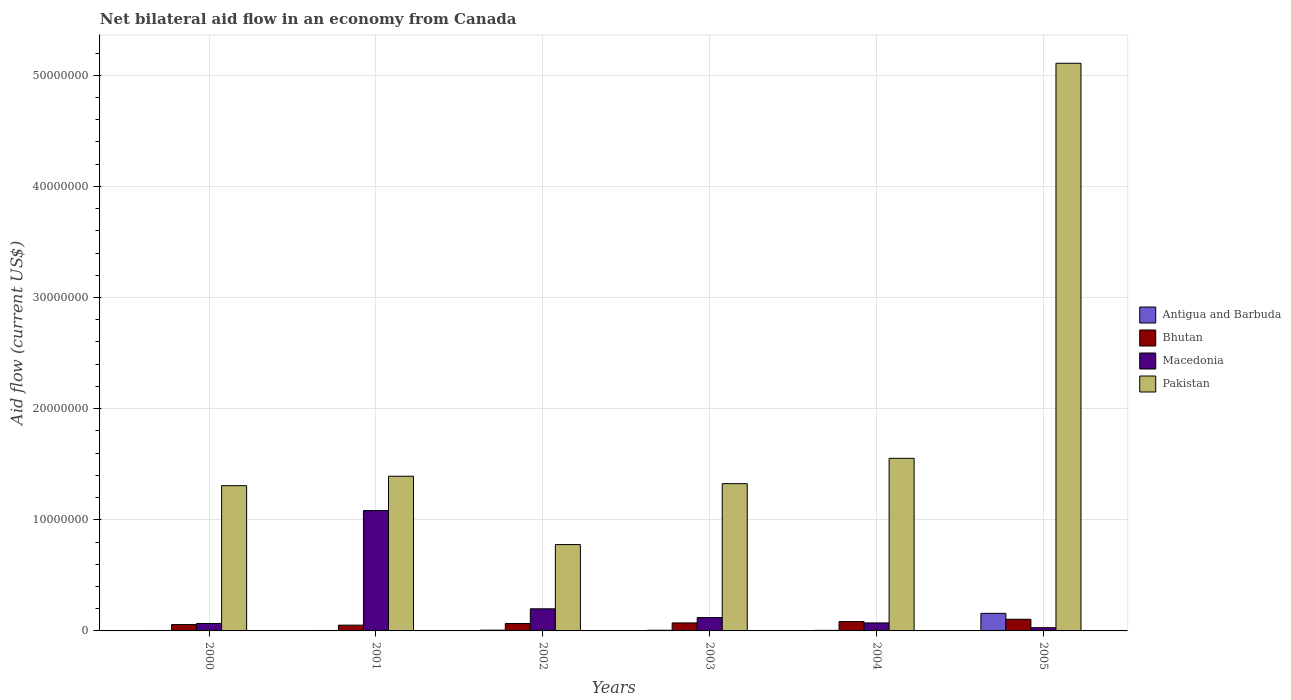How many different coloured bars are there?
Provide a short and direct response. 4. Are the number of bars per tick equal to the number of legend labels?
Provide a short and direct response. Yes. Are the number of bars on each tick of the X-axis equal?
Offer a terse response. Yes. How many bars are there on the 3rd tick from the right?
Give a very brief answer. 4. What is the label of the 3rd group of bars from the left?
Your answer should be very brief. 2002. In how many cases, is the number of bars for a given year not equal to the number of legend labels?
Make the answer very short. 0. Across all years, what is the maximum net bilateral aid flow in Pakistan?
Your response must be concise. 5.11e+07. Across all years, what is the minimum net bilateral aid flow in Macedonia?
Your answer should be very brief. 2.90e+05. In which year was the net bilateral aid flow in Macedonia maximum?
Provide a succinct answer. 2001. In which year was the net bilateral aid flow in Antigua and Barbuda minimum?
Give a very brief answer. 2000. What is the total net bilateral aid flow in Macedonia in the graph?
Your response must be concise. 1.57e+07. What is the difference between the net bilateral aid flow in Pakistan in 2000 and that in 2001?
Make the answer very short. -8.50e+05. What is the difference between the net bilateral aid flow in Macedonia in 2003 and the net bilateral aid flow in Antigua and Barbuda in 2002?
Ensure brevity in your answer.  1.13e+06. What is the average net bilateral aid flow in Pakistan per year?
Provide a succinct answer. 1.91e+07. In the year 2000, what is the difference between the net bilateral aid flow in Pakistan and net bilateral aid flow in Bhutan?
Provide a succinct answer. 1.25e+07. What is the ratio of the net bilateral aid flow in Antigua and Barbuda in 2000 to that in 2005?
Provide a short and direct response. 0.03. What is the difference between the highest and the second highest net bilateral aid flow in Macedonia?
Your answer should be compact. 8.84e+06. What is the difference between the highest and the lowest net bilateral aid flow in Pakistan?
Your answer should be compact. 4.33e+07. In how many years, is the net bilateral aid flow in Pakistan greater than the average net bilateral aid flow in Pakistan taken over all years?
Keep it short and to the point. 1. Is the sum of the net bilateral aid flow in Antigua and Barbuda in 2000 and 2004 greater than the maximum net bilateral aid flow in Bhutan across all years?
Offer a terse response. No. What does the 4th bar from the right in 2003 represents?
Make the answer very short. Antigua and Barbuda. Is it the case that in every year, the sum of the net bilateral aid flow in Pakistan and net bilateral aid flow in Antigua and Barbuda is greater than the net bilateral aid flow in Bhutan?
Your response must be concise. Yes. What is the difference between two consecutive major ticks on the Y-axis?
Your answer should be compact. 1.00e+07. Are the values on the major ticks of Y-axis written in scientific E-notation?
Your response must be concise. No. Does the graph contain grids?
Provide a succinct answer. Yes. Where does the legend appear in the graph?
Provide a short and direct response. Center right. How many legend labels are there?
Offer a very short reply. 4. What is the title of the graph?
Offer a very short reply. Net bilateral aid flow in an economy from Canada. What is the Aid flow (current US$) in Antigua and Barbuda in 2000?
Provide a succinct answer. 4.00e+04. What is the Aid flow (current US$) in Bhutan in 2000?
Your response must be concise. 5.70e+05. What is the Aid flow (current US$) of Macedonia in 2000?
Offer a terse response. 6.70e+05. What is the Aid flow (current US$) of Pakistan in 2000?
Your answer should be compact. 1.31e+07. What is the Aid flow (current US$) of Antigua and Barbuda in 2001?
Offer a very short reply. 4.00e+04. What is the Aid flow (current US$) in Bhutan in 2001?
Provide a succinct answer. 5.20e+05. What is the Aid flow (current US$) of Macedonia in 2001?
Your response must be concise. 1.08e+07. What is the Aid flow (current US$) in Pakistan in 2001?
Ensure brevity in your answer.  1.39e+07. What is the Aid flow (current US$) of Antigua and Barbuda in 2002?
Give a very brief answer. 7.00e+04. What is the Aid flow (current US$) of Bhutan in 2002?
Offer a very short reply. 6.70e+05. What is the Aid flow (current US$) of Macedonia in 2002?
Provide a short and direct response. 1.99e+06. What is the Aid flow (current US$) in Pakistan in 2002?
Your response must be concise. 7.77e+06. What is the Aid flow (current US$) in Bhutan in 2003?
Your answer should be very brief. 7.20e+05. What is the Aid flow (current US$) of Macedonia in 2003?
Your response must be concise. 1.20e+06. What is the Aid flow (current US$) of Pakistan in 2003?
Your answer should be compact. 1.32e+07. What is the Aid flow (current US$) of Bhutan in 2004?
Ensure brevity in your answer.  8.40e+05. What is the Aid flow (current US$) of Macedonia in 2004?
Ensure brevity in your answer.  7.20e+05. What is the Aid flow (current US$) in Pakistan in 2004?
Give a very brief answer. 1.55e+07. What is the Aid flow (current US$) in Antigua and Barbuda in 2005?
Give a very brief answer. 1.58e+06. What is the Aid flow (current US$) in Bhutan in 2005?
Your answer should be compact. 1.05e+06. What is the Aid flow (current US$) in Macedonia in 2005?
Make the answer very short. 2.90e+05. What is the Aid flow (current US$) in Pakistan in 2005?
Make the answer very short. 5.11e+07. Across all years, what is the maximum Aid flow (current US$) in Antigua and Barbuda?
Your answer should be very brief. 1.58e+06. Across all years, what is the maximum Aid flow (current US$) of Bhutan?
Your response must be concise. 1.05e+06. Across all years, what is the maximum Aid flow (current US$) of Macedonia?
Keep it short and to the point. 1.08e+07. Across all years, what is the maximum Aid flow (current US$) of Pakistan?
Provide a succinct answer. 5.11e+07. Across all years, what is the minimum Aid flow (current US$) of Antigua and Barbuda?
Ensure brevity in your answer.  4.00e+04. Across all years, what is the minimum Aid flow (current US$) of Bhutan?
Your answer should be very brief. 5.20e+05. Across all years, what is the minimum Aid flow (current US$) of Macedonia?
Provide a short and direct response. 2.90e+05. Across all years, what is the minimum Aid flow (current US$) of Pakistan?
Your answer should be compact. 7.77e+06. What is the total Aid flow (current US$) of Antigua and Barbuda in the graph?
Provide a succinct answer. 1.84e+06. What is the total Aid flow (current US$) in Bhutan in the graph?
Provide a succinct answer. 4.37e+06. What is the total Aid flow (current US$) in Macedonia in the graph?
Ensure brevity in your answer.  1.57e+07. What is the total Aid flow (current US$) in Pakistan in the graph?
Offer a very short reply. 1.15e+08. What is the difference between the Aid flow (current US$) in Macedonia in 2000 and that in 2001?
Offer a very short reply. -1.02e+07. What is the difference between the Aid flow (current US$) of Pakistan in 2000 and that in 2001?
Your answer should be compact. -8.50e+05. What is the difference between the Aid flow (current US$) of Antigua and Barbuda in 2000 and that in 2002?
Give a very brief answer. -3.00e+04. What is the difference between the Aid flow (current US$) of Macedonia in 2000 and that in 2002?
Provide a short and direct response. -1.32e+06. What is the difference between the Aid flow (current US$) of Pakistan in 2000 and that in 2002?
Provide a succinct answer. 5.30e+06. What is the difference between the Aid flow (current US$) in Bhutan in 2000 and that in 2003?
Make the answer very short. -1.50e+05. What is the difference between the Aid flow (current US$) of Macedonia in 2000 and that in 2003?
Make the answer very short. -5.30e+05. What is the difference between the Aid flow (current US$) of Pakistan in 2000 and that in 2003?
Ensure brevity in your answer.  -1.80e+05. What is the difference between the Aid flow (current US$) of Antigua and Barbuda in 2000 and that in 2004?
Provide a short and direct response. -10000. What is the difference between the Aid flow (current US$) in Bhutan in 2000 and that in 2004?
Keep it short and to the point. -2.70e+05. What is the difference between the Aid flow (current US$) of Pakistan in 2000 and that in 2004?
Your response must be concise. -2.46e+06. What is the difference between the Aid flow (current US$) in Antigua and Barbuda in 2000 and that in 2005?
Offer a terse response. -1.54e+06. What is the difference between the Aid flow (current US$) in Bhutan in 2000 and that in 2005?
Provide a short and direct response. -4.80e+05. What is the difference between the Aid flow (current US$) in Macedonia in 2000 and that in 2005?
Your answer should be compact. 3.80e+05. What is the difference between the Aid flow (current US$) of Pakistan in 2000 and that in 2005?
Keep it short and to the point. -3.80e+07. What is the difference between the Aid flow (current US$) in Antigua and Barbuda in 2001 and that in 2002?
Keep it short and to the point. -3.00e+04. What is the difference between the Aid flow (current US$) of Bhutan in 2001 and that in 2002?
Your answer should be very brief. -1.50e+05. What is the difference between the Aid flow (current US$) in Macedonia in 2001 and that in 2002?
Give a very brief answer. 8.84e+06. What is the difference between the Aid flow (current US$) in Pakistan in 2001 and that in 2002?
Your answer should be very brief. 6.15e+06. What is the difference between the Aid flow (current US$) in Antigua and Barbuda in 2001 and that in 2003?
Your response must be concise. -2.00e+04. What is the difference between the Aid flow (current US$) of Bhutan in 2001 and that in 2003?
Your response must be concise. -2.00e+05. What is the difference between the Aid flow (current US$) of Macedonia in 2001 and that in 2003?
Keep it short and to the point. 9.63e+06. What is the difference between the Aid flow (current US$) of Pakistan in 2001 and that in 2003?
Make the answer very short. 6.70e+05. What is the difference between the Aid flow (current US$) in Antigua and Barbuda in 2001 and that in 2004?
Your response must be concise. -10000. What is the difference between the Aid flow (current US$) in Bhutan in 2001 and that in 2004?
Give a very brief answer. -3.20e+05. What is the difference between the Aid flow (current US$) in Macedonia in 2001 and that in 2004?
Provide a succinct answer. 1.01e+07. What is the difference between the Aid flow (current US$) in Pakistan in 2001 and that in 2004?
Provide a short and direct response. -1.61e+06. What is the difference between the Aid flow (current US$) in Antigua and Barbuda in 2001 and that in 2005?
Provide a short and direct response. -1.54e+06. What is the difference between the Aid flow (current US$) in Bhutan in 2001 and that in 2005?
Provide a succinct answer. -5.30e+05. What is the difference between the Aid flow (current US$) of Macedonia in 2001 and that in 2005?
Offer a terse response. 1.05e+07. What is the difference between the Aid flow (current US$) in Pakistan in 2001 and that in 2005?
Give a very brief answer. -3.72e+07. What is the difference between the Aid flow (current US$) in Macedonia in 2002 and that in 2003?
Provide a succinct answer. 7.90e+05. What is the difference between the Aid flow (current US$) in Pakistan in 2002 and that in 2003?
Your response must be concise. -5.48e+06. What is the difference between the Aid flow (current US$) in Macedonia in 2002 and that in 2004?
Your answer should be very brief. 1.27e+06. What is the difference between the Aid flow (current US$) in Pakistan in 2002 and that in 2004?
Ensure brevity in your answer.  -7.76e+06. What is the difference between the Aid flow (current US$) of Antigua and Barbuda in 2002 and that in 2005?
Offer a very short reply. -1.51e+06. What is the difference between the Aid flow (current US$) in Bhutan in 2002 and that in 2005?
Your answer should be very brief. -3.80e+05. What is the difference between the Aid flow (current US$) in Macedonia in 2002 and that in 2005?
Your response must be concise. 1.70e+06. What is the difference between the Aid flow (current US$) in Pakistan in 2002 and that in 2005?
Ensure brevity in your answer.  -4.33e+07. What is the difference between the Aid flow (current US$) of Macedonia in 2003 and that in 2004?
Provide a short and direct response. 4.80e+05. What is the difference between the Aid flow (current US$) in Pakistan in 2003 and that in 2004?
Give a very brief answer. -2.28e+06. What is the difference between the Aid flow (current US$) in Antigua and Barbuda in 2003 and that in 2005?
Ensure brevity in your answer.  -1.52e+06. What is the difference between the Aid flow (current US$) of Bhutan in 2003 and that in 2005?
Offer a terse response. -3.30e+05. What is the difference between the Aid flow (current US$) of Macedonia in 2003 and that in 2005?
Your answer should be compact. 9.10e+05. What is the difference between the Aid flow (current US$) in Pakistan in 2003 and that in 2005?
Provide a short and direct response. -3.78e+07. What is the difference between the Aid flow (current US$) of Antigua and Barbuda in 2004 and that in 2005?
Provide a succinct answer. -1.53e+06. What is the difference between the Aid flow (current US$) in Bhutan in 2004 and that in 2005?
Your response must be concise. -2.10e+05. What is the difference between the Aid flow (current US$) in Macedonia in 2004 and that in 2005?
Provide a short and direct response. 4.30e+05. What is the difference between the Aid flow (current US$) in Pakistan in 2004 and that in 2005?
Keep it short and to the point. -3.56e+07. What is the difference between the Aid flow (current US$) in Antigua and Barbuda in 2000 and the Aid flow (current US$) in Bhutan in 2001?
Your answer should be compact. -4.80e+05. What is the difference between the Aid flow (current US$) in Antigua and Barbuda in 2000 and the Aid flow (current US$) in Macedonia in 2001?
Your answer should be compact. -1.08e+07. What is the difference between the Aid flow (current US$) of Antigua and Barbuda in 2000 and the Aid flow (current US$) of Pakistan in 2001?
Offer a very short reply. -1.39e+07. What is the difference between the Aid flow (current US$) in Bhutan in 2000 and the Aid flow (current US$) in Macedonia in 2001?
Ensure brevity in your answer.  -1.03e+07. What is the difference between the Aid flow (current US$) of Bhutan in 2000 and the Aid flow (current US$) of Pakistan in 2001?
Your response must be concise. -1.34e+07. What is the difference between the Aid flow (current US$) in Macedonia in 2000 and the Aid flow (current US$) in Pakistan in 2001?
Your answer should be very brief. -1.32e+07. What is the difference between the Aid flow (current US$) in Antigua and Barbuda in 2000 and the Aid flow (current US$) in Bhutan in 2002?
Ensure brevity in your answer.  -6.30e+05. What is the difference between the Aid flow (current US$) in Antigua and Barbuda in 2000 and the Aid flow (current US$) in Macedonia in 2002?
Keep it short and to the point. -1.95e+06. What is the difference between the Aid flow (current US$) of Antigua and Barbuda in 2000 and the Aid flow (current US$) of Pakistan in 2002?
Your answer should be compact. -7.73e+06. What is the difference between the Aid flow (current US$) in Bhutan in 2000 and the Aid flow (current US$) in Macedonia in 2002?
Keep it short and to the point. -1.42e+06. What is the difference between the Aid flow (current US$) in Bhutan in 2000 and the Aid flow (current US$) in Pakistan in 2002?
Provide a succinct answer. -7.20e+06. What is the difference between the Aid flow (current US$) in Macedonia in 2000 and the Aid flow (current US$) in Pakistan in 2002?
Ensure brevity in your answer.  -7.10e+06. What is the difference between the Aid flow (current US$) of Antigua and Barbuda in 2000 and the Aid flow (current US$) of Bhutan in 2003?
Your answer should be compact. -6.80e+05. What is the difference between the Aid flow (current US$) in Antigua and Barbuda in 2000 and the Aid flow (current US$) in Macedonia in 2003?
Your response must be concise. -1.16e+06. What is the difference between the Aid flow (current US$) of Antigua and Barbuda in 2000 and the Aid flow (current US$) of Pakistan in 2003?
Make the answer very short. -1.32e+07. What is the difference between the Aid flow (current US$) of Bhutan in 2000 and the Aid flow (current US$) of Macedonia in 2003?
Offer a terse response. -6.30e+05. What is the difference between the Aid flow (current US$) in Bhutan in 2000 and the Aid flow (current US$) in Pakistan in 2003?
Ensure brevity in your answer.  -1.27e+07. What is the difference between the Aid flow (current US$) in Macedonia in 2000 and the Aid flow (current US$) in Pakistan in 2003?
Offer a terse response. -1.26e+07. What is the difference between the Aid flow (current US$) in Antigua and Barbuda in 2000 and the Aid flow (current US$) in Bhutan in 2004?
Keep it short and to the point. -8.00e+05. What is the difference between the Aid flow (current US$) of Antigua and Barbuda in 2000 and the Aid flow (current US$) of Macedonia in 2004?
Offer a terse response. -6.80e+05. What is the difference between the Aid flow (current US$) of Antigua and Barbuda in 2000 and the Aid flow (current US$) of Pakistan in 2004?
Give a very brief answer. -1.55e+07. What is the difference between the Aid flow (current US$) of Bhutan in 2000 and the Aid flow (current US$) of Macedonia in 2004?
Provide a short and direct response. -1.50e+05. What is the difference between the Aid flow (current US$) in Bhutan in 2000 and the Aid flow (current US$) in Pakistan in 2004?
Offer a very short reply. -1.50e+07. What is the difference between the Aid flow (current US$) in Macedonia in 2000 and the Aid flow (current US$) in Pakistan in 2004?
Provide a succinct answer. -1.49e+07. What is the difference between the Aid flow (current US$) of Antigua and Barbuda in 2000 and the Aid flow (current US$) of Bhutan in 2005?
Ensure brevity in your answer.  -1.01e+06. What is the difference between the Aid flow (current US$) in Antigua and Barbuda in 2000 and the Aid flow (current US$) in Macedonia in 2005?
Your answer should be very brief. -2.50e+05. What is the difference between the Aid flow (current US$) of Antigua and Barbuda in 2000 and the Aid flow (current US$) of Pakistan in 2005?
Your response must be concise. -5.10e+07. What is the difference between the Aid flow (current US$) of Bhutan in 2000 and the Aid flow (current US$) of Pakistan in 2005?
Keep it short and to the point. -5.05e+07. What is the difference between the Aid flow (current US$) in Macedonia in 2000 and the Aid flow (current US$) in Pakistan in 2005?
Your answer should be very brief. -5.04e+07. What is the difference between the Aid flow (current US$) in Antigua and Barbuda in 2001 and the Aid flow (current US$) in Bhutan in 2002?
Make the answer very short. -6.30e+05. What is the difference between the Aid flow (current US$) of Antigua and Barbuda in 2001 and the Aid flow (current US$) of Macedonia in 2002?
Provide a succinct answer. -1.95e+06. What is the difference between the Aid flow (current US$) in Antigua and Barbuda in 2001 and the Aid flow (current US$) in Pakistan in 2002?
Provide a short and direct response. -7.73e+06. What is the difference between the Aid flow (current US$) in Bhutan in 2001 and the Aid flow (current US$) in Macedonia in 2002?
Make the answer very short. -1.47e+06. What is the difference between the Aid flow (current US$) in Bhutan in 2001 and the Aid flow (current US$) in Pakistan in 2002?
Provide a short and direct response. -7.25e+06. What is the difference between the Aid flow (current US$) in Macedonia in 2001 and the Aid flow (current US$) in Pakistan in 2002?
Make the answer very short. 3.06e+06. What is the difference between the Aid flow (current US$) in Antigua and Barbuda in 2001 and the Aid flow (current US$) in Bhutan in 2003?
Keep it short and to the point. -6.80e+05. What is the difference between the Aid flow (current US$) in Antigua and Barbuda in 2001 and the Aid flow (current US$) in Macedonia in 2003?
Keep it short and to the point. -1.16e+06. What is the difference between the Aid flow (current US$) in Antigua and Barbuda in 2001 and the Aid flow (current US$) in Pakistan in 2003?
Your answer should be very brief. -1.32e+07. What is the difference between the Aid flow (current US$) in Bhutan in 2001 and the Aid flow (current US$) in Macedonia in 2003?
Offer a terse response. -6.80e+05. What is the difference between the Aid flow (current US$) in Bhutan in 2001 and the Aid flow (current US$) in Pakistan in 2003?
Your response must be concise. -1.27e+07. What is the difference between the Aid flow (current US$) of Macedonia in 2001 and the Aid flow (current US$) of Pakistan in 2003?
Ensure brevity in your answer.  -2.42e+06. What is the difference between the Aid flow (current US$) in Antigua and Barbuda in 2001 and the Aid flow (current US$) in Bhutan in 2004?
Ensure brevity in your answer.  -8.00e+05. What is the difference between the Aid flow (current US$) of Antigua and Barbuda in 2001 and the Aid flow (current US$) of Macedonia in 2004?
Give a very brief answer. -6.80e+05. What is the difference between the Aid flow (current US$) of Antigua and Barbuda in 2001 and the Aid flow (current US$) of Pakistan in 2004?
Offer a terse response. -1.55e+07. What is the difference between the Aid flow (current US$) in Bhutan in 2001 and the Aid flow (current US$) in Pakistan in 2004?
Make the answer very short. -1.50e+07. What is the difference between the Aid flow (current US$) in Macedonia in 2001 and the Aid flow (current US$) in Pakistan in 2004?
Keep it short and to the point. -4.70e+06. What is the difference between the Aid flow (current US$) of Antigua and Barbuda in 2001 and the Aid flow (current US$) of Bhutan in 2005?
Your answer should be compact. -1.01e+06. What is the difference between the Aid flow (current US$) of Antigua and Barbuda in 2001 and the Aid flow (current US$) of Pakistan in 2005?
Your answer should be very brief. -5.10e+07. What is the difference between the Aid flow (current US$) in Bhutan in 2001 and the Aid flow (current US$) in Macedonia in 2005?
Offer a terse response. 2.30e+05. What is the difference between the Aid flow (current US$) in Bhutan in 2001 and the Aid flow (current US$) in Pakistan in 2005?
Make the answer very short. -5.06e+07. What is the difference between the Aid flow (current US$) in Macedonia in 2001 and the Aid flow (current US$) in Pakistan in 2005?
Your response must be concise. -4.02e+07. What is the difference between the Aid flow (current US$) of Antigua and Barbuda in 2002 and the Aid flow (current US$) of Bhutan in 2003?
Provide a short and direct response. -6.50e+05. What is the difference between the Aid flow (current US$) in Antigua and Barbuda in 2002 and the Aid flow (current US$) in Macedonia in 2003?
Your response must be concise. -1.13e+06. What is the difference between the Aid flow (current US$) in Antigua and Barbuda in 2002 and the Aid flow (current US$) in Pakistan in 2003?
Give a very brief answer. -1.32e+07. What is the difference between the Aid flow (current US$) in Bhutan in 2002 and the Aid flow (current US$) in Macedonia in 2003?
Keep it short and to the point. -5.30e+05. What is the difference between the Aid flow (current US$) in Bhutan in 2002 and the Aid flow (current US$) in Pakistan in 2003?
Offer a terse response. -1.26e+07. What is the difference between the Aid flow (current US$) in Macedonia in 2002 and the Aid flow (current US$) in Pakistan in 2003?
Provide a short and direct response. -1.13e+07. What is the difference between the Aid flow (current US$) in Antigua and Barbuda in 2002 and the Aid flow (current US$) in Bhutan in 2004?
Give a very brief answer. -7.70e+05. What is the difference between the Aid flow (current US$) of Antigua and Barbuda in 2002 and the Aid flow (current US$) of Macedonia in 2004?
Your response must be concise. -6.50e+05. What is the difference between the Aid flow (current US$) in Antigua and Barbuda in 2002 and the Aid flow (current US$) in Pakistan in 2004?
Make the answer very short. -1.55e+07. What is the difference between the Aid flow (current US$) in Bhutan in 2002 and the Aid flow (current US$) in Pakistan in 2004?
Your response must be concise. -1.49e+07. What is the difference between the Aid flow (current US$) of Macedonia in 2002 and the Aid flow (current US$) of Pakistan in 2004?
Keep it short and to the point. -1.35e+07. What is the difference between the Aid flow (current US$) of Antigua and Barbuda in 2002 and the Aid flow (current US$) of Bhutan in 2005?
Make the answer very short. -9.80e+05. What is the difference between the Aid flow (current US$) of Antigua and Barbuda in 2002 and the Aid flow (current US$) of Macedonia in 2005?
Offer a very short reply. -2.20e+05. What is the difference between the Aid flow (current US$) of Antigua and Barbuda in 2002 and the Aid flow (current US$) of Pakistan in 2005?
Ensure brevity in your answer.  -5.10e+07. What is the difference between the Aid flow (current US$) of Bhutan in 2002 and the Aid flow (current US$) of Macedonia in 2005?
Your response must be concise. 3.80e+05. What is the difference between the Aid flow (current US$) of Bhutan in 2002 and the Aid flow (current US$) of Pakistan in 2005?
Your answer should be very brief. -5.04e+07. What is the difference between the Aid flow (current US$) of Macedonia in 2002 and the Aid flow (current US$) of Pakistan in 2005?
Keep it short and to the point. -4.91e+07. What is the difference between the Aid flow (current US$) in Antigua and Barbuda in 2003 and the Aid flow (current US$) in Bhutan in 2004?
Provide a short and direct response. -7.80e+05. What is the difference between the Aid flow (current US$) in Antigua and Barbuda in 2003 and the Aid flow (current US$) in Macedonia in 2004?
Make the answer very short. -6.60e+05. What is the difference between the Aid flow (current US$) of Antigua and Barbuda in 2003 and the Aid flow (current US$) of Pakistan in 2004?
Your response must be concise. -1.55e+07. What is the difference between the Aid flow (current US$) in Bhutan in 2003 and the Aid flow (current US$) in Macedonia in 2004?
Your response must be concise. 0. What is the difference between the Aid flow (current US$) of Bhutan in 2003 and the Aid flow (current US$) of Pakistan in 2004?
Give a very brief answer. -1.48e+07. What is the difference between the Aid flow (current US$) of Macedonia in 2003 and the Aid flow (current US$) of Pakistan in 2004?
Your answer should be very brief. -1.43e+07. What is the difference between the Aid flow (current US$) in Antigua and Barbuda in 2003 and the Aid flow (current US$) in Bhutan in 2005?
Your answer should be compact. -9.90e+05. What is the difference between the Aid flow (current US$) in Antigua and Barbuda in 2003 and the Aid flow (current US$) in Macedonia in 2005?
Make the answer very short. -2.30e+05. What is the difference between the Aid flow (current US$) in Antigua and Barbuda in 2003 and the Aid flow (current US$) in Pakistan in 2005?
Keep it short and to the point. -5.10e+07. What is the difference between the Aid flow (current US$) of Bhutan in 2003 and the Aid flow (current US$) of Pakistan in 2005?
Your response must be concise. -5.04e+07. What is the difference between the Aid flow (current US$) of Macedonia in 2003 and the Aid flow (current US$) of Pakistan in 2005?
Provide a succinct answer. -4.99e+07. What is the difference between the Aid flow (current US$) of Antigua and Barbuda in 2004 and the Aid flow (current US$) of Macedonia in 2005?
Keep it short and to the point. -2.40e+05. What is the difference between the Aid flow (current US$) in Antigua and Barbuda in 2004 and the Aid flow (current US$) in Pakistan in 2005?
Give a very brief answer. -5.10e+07. What is the difference between the Aid flow (current US$) of Bhutan in 2004 and the Aid flow (current US$) of Macedonia in 2005?
Your answer should be very brief. 5.50e+05. What is the difference between the Aid flow (current US$) of Bhutan in 2004 and the Aid flow (current US$) of Pakistan in 2005?
Make the answer very short. -5.02e+07. What is the difference between the Aid flow (current US$) of Macedonia in 2004 and the Aid flow (current US$) of Pakistan in 2005?
Make the answer very short. -5.04e+07. What is the average Aid flow (current US$) of Antigua and Barbuda per year?
Offer a terse response. 3.07e+05. What is the average Aid flow (current US$) in Bhutan per year?
Offer a terse response. 7.28e+05. What is the average Aid flow (current US$) in Macedonia per year?
Your answer should be very brief. 2.62e+06. What is the average Aid flow (current US$) of Pakistan per year?
Keep it short and to the point. 1.91e+07. In the year 2000, what is the difference between the Aid flow (current US$) in Antigua and Barbuda and Aid flow (current US$) in Bhutan?
Your answer should be very brief. -5.30e+05. In the year 2000, what is the difference between the Aid flow (current US$) of Antigua and Barbuda and Aid flow (current US$) of Macedonia?
Ensure brevity in your answer.  -6.30e+05. In the year 2000, what is the difference between the Aid flow (current US$) in Antigua and Barbuda and Aid flow (current US$) in Pakistan?
Give a very brief answer. -1.30e+07. In the year 2000, what is the difference between the Aid flow (current US$) of Bhutan and Aid flow (current US$) of Pakistan?
Ensure brevity in your answer.  -1.25e+07. In the year 2000, what is the difference between the Aid flow (current US$) of Macedonia and Aid flow (current US$) of Pakistan?
Your answer should be compact. -1.24e+07. In the year 2001, what is the difference between the Aid flow (current US$) in Antigua and Barbuda and Aid flow (current US$) in Bhutan?
Provide a succinct answer. -4.80e+05. In the year 2001, what is the difference between the Aid flow (current US$) of Antigua and Barbuda and Aid flow (current US$) of Macedonia?
Ensure brevity in your answer.  -1.08e+07. In the year 2001, what is the difference between the Aid flow (current US$) in Antigua and Barbuda and Aid flow (current US$) in Pakistan?
Ensure brevity in your answer.  -1.39e+07. In the year 2001, what is the difference between the Aid flow (current US$) in Bhutan and Aid flow (current US$) in Macedonia?
Give a very brief answer. -1.03e+07. In the year 2001, what is the difference between the Aid flow (current US$) of Bhutan and Aid flow (current US$) of Pakistan?
Make the answer very short. -1.34e+07. In the year 2001, what is the difference between the Aid flow (current US$) in Macedonia and Aid flow (current US$) in Pakistan?
Give a very brief answer. -3.09e+06. In the year 2002, what is the difference between the Aid flow (current US$) of Antigua and Barbuda and Aid flow (current US$) of Bhutan?
Provide a short and direct response. -6.00e+05. In the year 2002, what is the difference between the Aid flow (current US$) in Antigua and Barbuda and Aid flow (current US$) in Macedonia?
Keep it short and to the point. -1.92e+06. In the year 2002, what is the difference between the Aid flow (current US$) of Antigua and Barbuda and Aid flow (current US$) of Pakistan?
Make the answer very short. -7.70e+06. In the year 2002, what is the difference between the Aid flow (current US$) of Bhutan and Aid flow (current US$) of Macedonia?
Give a very brief answer. -1.32e+06. In the year 2002, what is the difference between the Aid flow (current US$) of Bhutan and Aid flow (current US$) of Pakistan?
Your answer should be very brief. -7.10e+06. In the year 2002, what is the difference between the Aid flow (current US$) of Macedonia and Aid flow (current US$) of Pakistan?
Your answer should be very brief. -5.78e+06. In the year 2003, what is the difference between the Aid flow (current US$) in Antigua and Barbuda and Aid flow (current US$) in Bhutan?
Your answer should be compact. -6.60e+05. In the year 2003, what is the difference between the Aid flow (current US$) in Antigua and Barbuda and Aid flow (current US$) in Macedonia?
Make the answer very short. -1.14e+06. In the year 2003, what is the difference between the Aid flow (current US$) of Antigua and Barbuda and Aid flow (current US$) of Pakistan?
Offer a terse response. -1.32e+07. In the year 2003, what is the difference between the Aid flow (current US$) of Bhutan and Aid flow (current US$) of Macedonia?
Offer a very short reply. -4.80e+05. In the year 2003, what is the difference between the Aid flow (current US$) in Bhutan and Aid flow (current US$) in Pakistan?
Your response must be concise. -1.25e+07. In the year 2003, what is the difference between the Aid flow (current US$) in Macedonia and Aid flow (current US$) in Pakistan?
Ensure brevity in your answer.  -1.20e+07. In the year 2004, what is the difference between the Aid flow (current US$) of Antigua and Barbuda and Aid flow (current US$) of Bhutan?
Offer a very short reply. -7.90e+05. In the year 2004, what is the difference between the Aid flow (current US$) of Antigua and Barbuda and Aid flow (current US$) of Macedonia?
Provide a succinct answer. -6.70e+05. In the year 2004, what is the difference between the Aid flow (current US$) in Antigua and Barbuda and Aid flow (current US$) in Pakistan?
Provide a short and direct response. -1.55e+07. In the year 2004, what is the difference between the Aid flow (current US$) in Bhutan and Aid flow (current US$) in Macedonia?
Ensure brevity in your answer.  1.20e+05. In the year 2004, what is the difference between the Aid flow (current US$) in Bhutan and Aid flow (current US$) in Pakistan?
Your answer should be very brief. -1.47e+07. In the year 2004, what is the difference between the Aid flow (current US$) in Macedonia and Aid flow (current US$) in Pakistan?
Give a very brief answer. -1.48e+07. In the year 2005, what is the difference between the Aid flow (current US$) of Antigua and Barbuda and Aid flow (current US$) of Bhutan?
Give a very brief answer. 5.30e+05. In the year 2005, what is the difference between the Aid flow (current US$) of Antigua and Barbuda and Aid flow (current US$) of Macedonia?
Your answer should be very brief. 1.29e+06. In the year 2005, what is the difference between the Aid flow (current US$) in Antigua and Barbuda and Aid flow (current US$) in Pakistan?
Your response must be concise. -4.95e+07. In the year 2005, what is the difference between the Aid flow (current US$) in Bhutan and Aid flow (current US$) in Macedonia?
Keep it short and to the point. 7.60e+05. In the year 2005, what is the difference between the Aid flow (current US$) in Bhutan and Aid flow (current US$) in Pakistan?
Provide a succinct answer. -5.00e+07. In the year 2005, what is the difference between the Aid flow (current US$) of Macedonia and Aid flow (current US$) of Pakistan?
Offer a terse response. -5.08e+07. What is the ratio of the Aid flow (current US$) of Antigua and Barbuda in 2000 to that in 2001?
Keep it short and to the point. 1. What is the ratio of the Aid flow (current US$) in Bhutan in 2000 to that in 2001?
Offer a very short reply. 1.1. What is the ratio of the Aid flow (current US$) of Macedonia in 2000 to that in 2001?
Offer a terse response. 0.06. What is the ratio of the Aid flow (current US$) in Pakistan in 2000 to that in 2001?
Your answer should be very brief. 0.94. What is the ratio of the Aid flow (current US$) in Bhutan in 2000 to that in 2002?
Keep it short and to the point. 0.85. What is the ratio of the Aid flow (current US$) in Macedonia in 2000 to that in 2002?
Keep it short and to the point. 0.34. What is the ratio of the Aid flow (current US$) of Pakistan in 2000 to that in 2002?
Offer a terse response. 1.68. What is the ratio of the Aid flow (current US$) in Antigua and Barbuda in 2000 to that in 2003?
Ensure brevity in your answer.  0.67. What is the ratio of the Aid flow (current US$) in Bhutan in 2000 to that in 2003?
Offer a very short reply. 0.79. What is the ratio of the Aid flow (current US$) of Macedonia in 2000 to that in 2003?
Provide a succinct answer. 0.56. What is the ratio of the Aid flow (current US$) of Pakistan in 2000 to that in 2003?
Your answer should be very brief. 0.99. What is the ratio of the Aid flow (current US$) of Bhutan in 2000 to that in 2004?
Give a very brief answer. 0.68. What is the ratio of the Aid flow (current US$) of Macedonia in 2000 to that in 2004?
Give a very brief answer. 0.93. What is the ratio of the Aid flow (current US$) of Pakistan in 2000 to that in 2004?
Offer a very short reply. 0.84. What is the ratio of the Aid flow (current US$) of Antigua and Barbuda in 2000 to that in 2005?
Your response must be concise. 0.03. What is the ratio of the Aid flow (current US$) of Bhutan in 2000 to that in 2005?
Make the answer very short. 0.54. What is the ratio of the Aid flow (current US$) in Macedonia in 2000 to that in 2005?
Provide a short and direct response. 2.31. What is the ratio of the Aid flow (current US$) in Pakistan in 2000 to that in 2005?
Make the answer very short. 0.26. What is the ratio of the Aid flow (current US$) in Bhutan in 2001 to that in 2002?
Make the answer very short. 0.78. What is the ratio of the Aid flow (current US$) of Macedonia in 2001 to that in 2002?
Offer a very short reply. 5.44. What is the ratio of the Aid flow (current US$) of Pakistan in 2001 to that in 2002?
Provide a short and direct response. 1.79. What is the ratio of the Aid flow (current US$) in Antigua and Barbuda in 2001 to that in 2003?
Offer a terse response. 0.67. What is the ratio of the Aid flow (current US$) of Bhutan in 2001 to that in 2003?
Give a very brief answer. 0.72. What is the ratio of the Aid flow (current US$) of Macedonia in 2001 to that in 2003?
Your response must be concise. 9.03. What is the ratio of the Aid flow (current US$) of Pakistan in 2001 to that in 2003?
Your answer should be compact. 1.05. What is the ratio of the Aid flow (current US$) in Bhutan in 2001 to that in 2004?
Make the answer very short. 0.62. What is the ratio of the Aid flow (current US$) in Macedonia in 2001 to that in 2004?
Your answer should be compact. 15.04. What is the ratio of the Aid flow (current US$) of Pakistan in 2001 to that in 2004?
Provide a succinct answer. 0.9. What is the ratio of the Aid flow (current US$) of Antigua and Barbuda in 2001 to that in 2005?
Keep it short and to the point. 0.03. What is the ratio of the Aid flow (current US$) in Bhutan in 2001 to that in 2005?
Ensure brevity in your answer.  0.5. What is the ratio of the Aid flow (current US$) in Macedonia in 2001 to that in 2005?
Your answer should be very brief. 37.34. What is the ratio of the Aid flow (current US$) in Pakistan in 2001 to that in 2005?
Your answer should be very brief. 0.27. What is the ratio of the Aid flow (current US$) of Antigua and Barbuda in 2002 to that in 2003?
Provide a short and direct response. 1.17. What is the ratio of the Aid flow (current US$) in Bhutan in 2002 to that in 2003?
Your answer should be very brief. 0.93. What is the ratio of the Aid flow (current US$) of Macedonia in 2002 to that in 2003?
Make the answer very short. 1.66. What is the ratio of the Aid flow (current US$) in Pakistan in 2002 to that in 2003?
Provide a succinct answer. 0.59. What is the ratio of the Aid flow (current US$) in Bhutan in 2002 to that in 2004?
Keep it short and to the point. 0.8. What is the ratio of the Aid flow (current US$) of Macedonia in 2002 to that in 2004?
Give a very brief answer. 2.76. What is the ratio of the Aid flow (current US$) of Pakistan in 2002 to that in 2004?
Provide a succinct answer. 0.5. What is the ratio of the Aid flow (current US$) in Antigua and Barbuda in 2002 to that in 2005?
Keep it short and to the point. 0.04. What is the ratio of the Aid flow (current US$) in Bhutan in 2002 to that in 2005?
Give a very brief answer. 0.64. What is the ratio of the Aid flow (current US$) in Macedonia in 2002 to that in 2005?
Offer a very short reply. 6.86. What is the ratio of the Aid flow (current US$) in Pakistan in 2002 to that in 2005?
Provide a short and direct response. 0.15. What is the ratio of the Aid flow (current US$) in Antigua and Barbuda in 2003 to that in 2004?
Give a very brief answer. 1.2. What is the ratio of the Aid flow (current US$) of Bhutan in 2003 to that in 2004?
Offer a terse response. 0.86. What is the ratio of the Aid flow (current US$) of Pakistan in 2003 to that in 2004?
Provide a short and direct response. 0.85. What is the ratio of the Aid flow (current US$) in Antigua and Barbuda in 2003 to that in 2005?
Make the answer very short. 0.04. What is the ratio of the Aid flow (current US$) in Bhutan in 2003 to that in 2005?
Your response must be concise. 0.69. What is the ratio of the Aid flow (current US$) in Macedonia in 2003 to that in 2005?
Provide a short and direct response. 4.14. What is the ratio of the Aid flow (current US$) of Pakistan in 2003 to that in 2005?
Offer a terse response. 0.26. What is the ratio of the Aid flow (current US$) in Antigua and Barbuda in 2004 to that in 2005?
Offer a very short reply. 0.03. What is the ratio of the Aid flow (current US$) in Macedonia in 2004 to that in 2005?
Keep it short and to the point. 2.48. What is the ratio of the Aid flow (current US$) in Pakistan in 2004 to that in 2005?
Your answer should be very brief. 0.3. What is the difference between the highest and the second highest Aid flow (current US$) in Antigua and Barbuda?
Your response must be concise. 1.51e+06. What is the difference between the highest and the second highest Aid flow (current US$) of Macedonia?
Your answer should be compact. 8.84e+06. What is the difference between the highest and the second highest Aid flow (current US$) of Pakistan?
Your answer should be very brief. 3.56e+07. What is the difference between the highest and the lowest Aid flow (current US$) in Antigua and Barbuda?
Give a very brief answer. 1.54e+06. What is the difference between the highest and the lowest Aid flow (current US$) in Bhutan?
Provide a succinct answer. 5.30e+05. What is the difference between the highest and the lowest Aid flow (current US$) of Macedonia?
Give a very brief answer. 1.05e+07. What is the difference between the highest and the lowest Aid flow (current US$) in Pakistan?
Ensure brevity in your answer.  4.33e+07. 